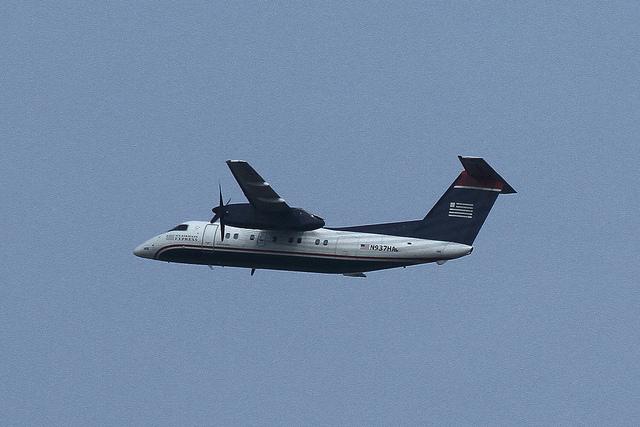How many planes can you see?
Be succinct. 1. Is this a commercial airline?
Keep it brief. Yes. What country flag is on the tail of the plane?
Short answer required. Usa. What are the numbers on plane?
Concise answer only. 937. Is the plane a jet?
Keep it brief. No. 